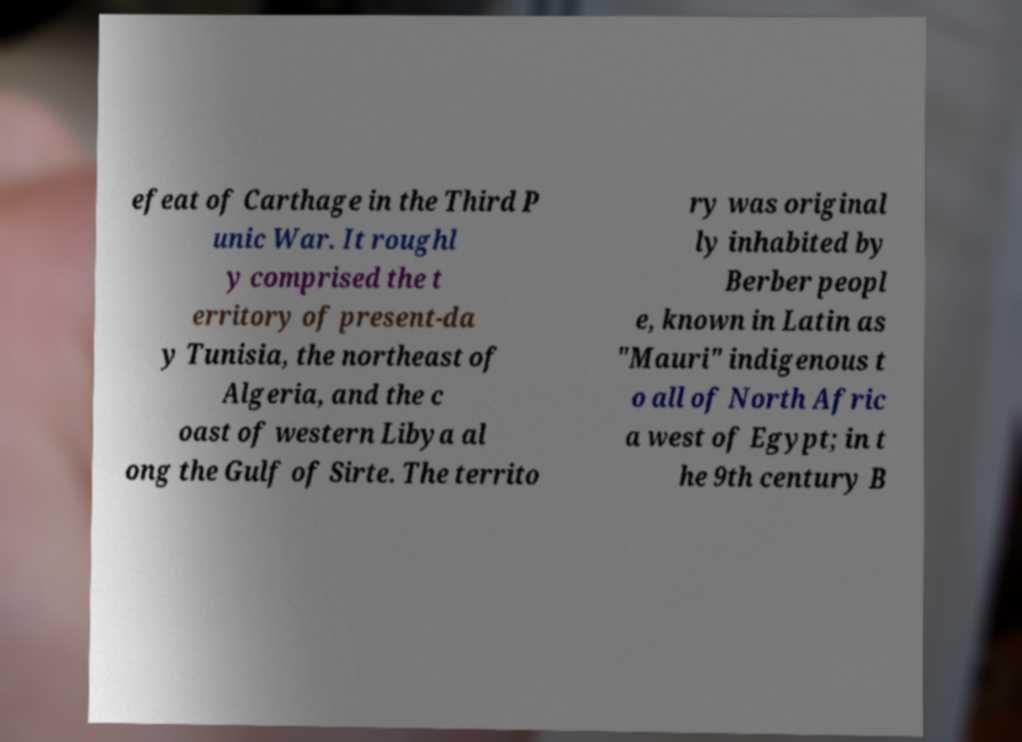Could you extract and type out the text from this image? efeat of Carthage in the Third P unic War. It roughl y comprised the t erritory of present-da y Tunisia, the northeast of Algeria, and the c oast of western Libya al ong the Gulf of Sirte. The territo ry was original ly inhabited by Berber peopl e, known in Latin as "Mauri" indigenous t o all of North Afric a west of Egypt; in t he 9th century B 